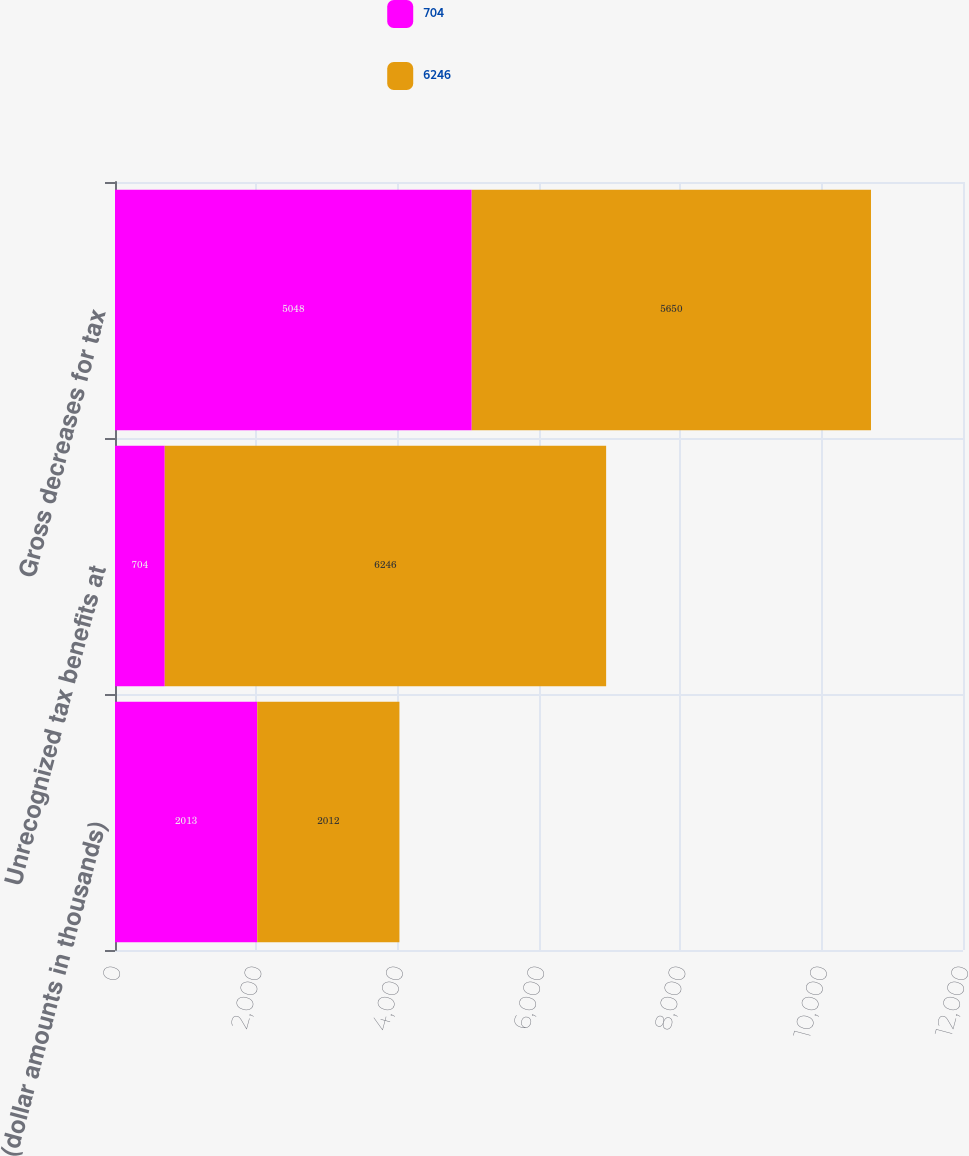Convert chart to OTSL. <chart><loc_0><loc_0><loc_500><loc_500><stacked_bar_chart><ecel><fcel>(dollar amounts in thousands)<fcel>Unrecognized tax benefits at<fcel>Gross decreases for tax<nl><fcel>704<fcel>2013<fcel>704<fcel>5048<nl><fcel>6246<fcel>2012<fcel>6246<fcel>5650<nl></chart> 